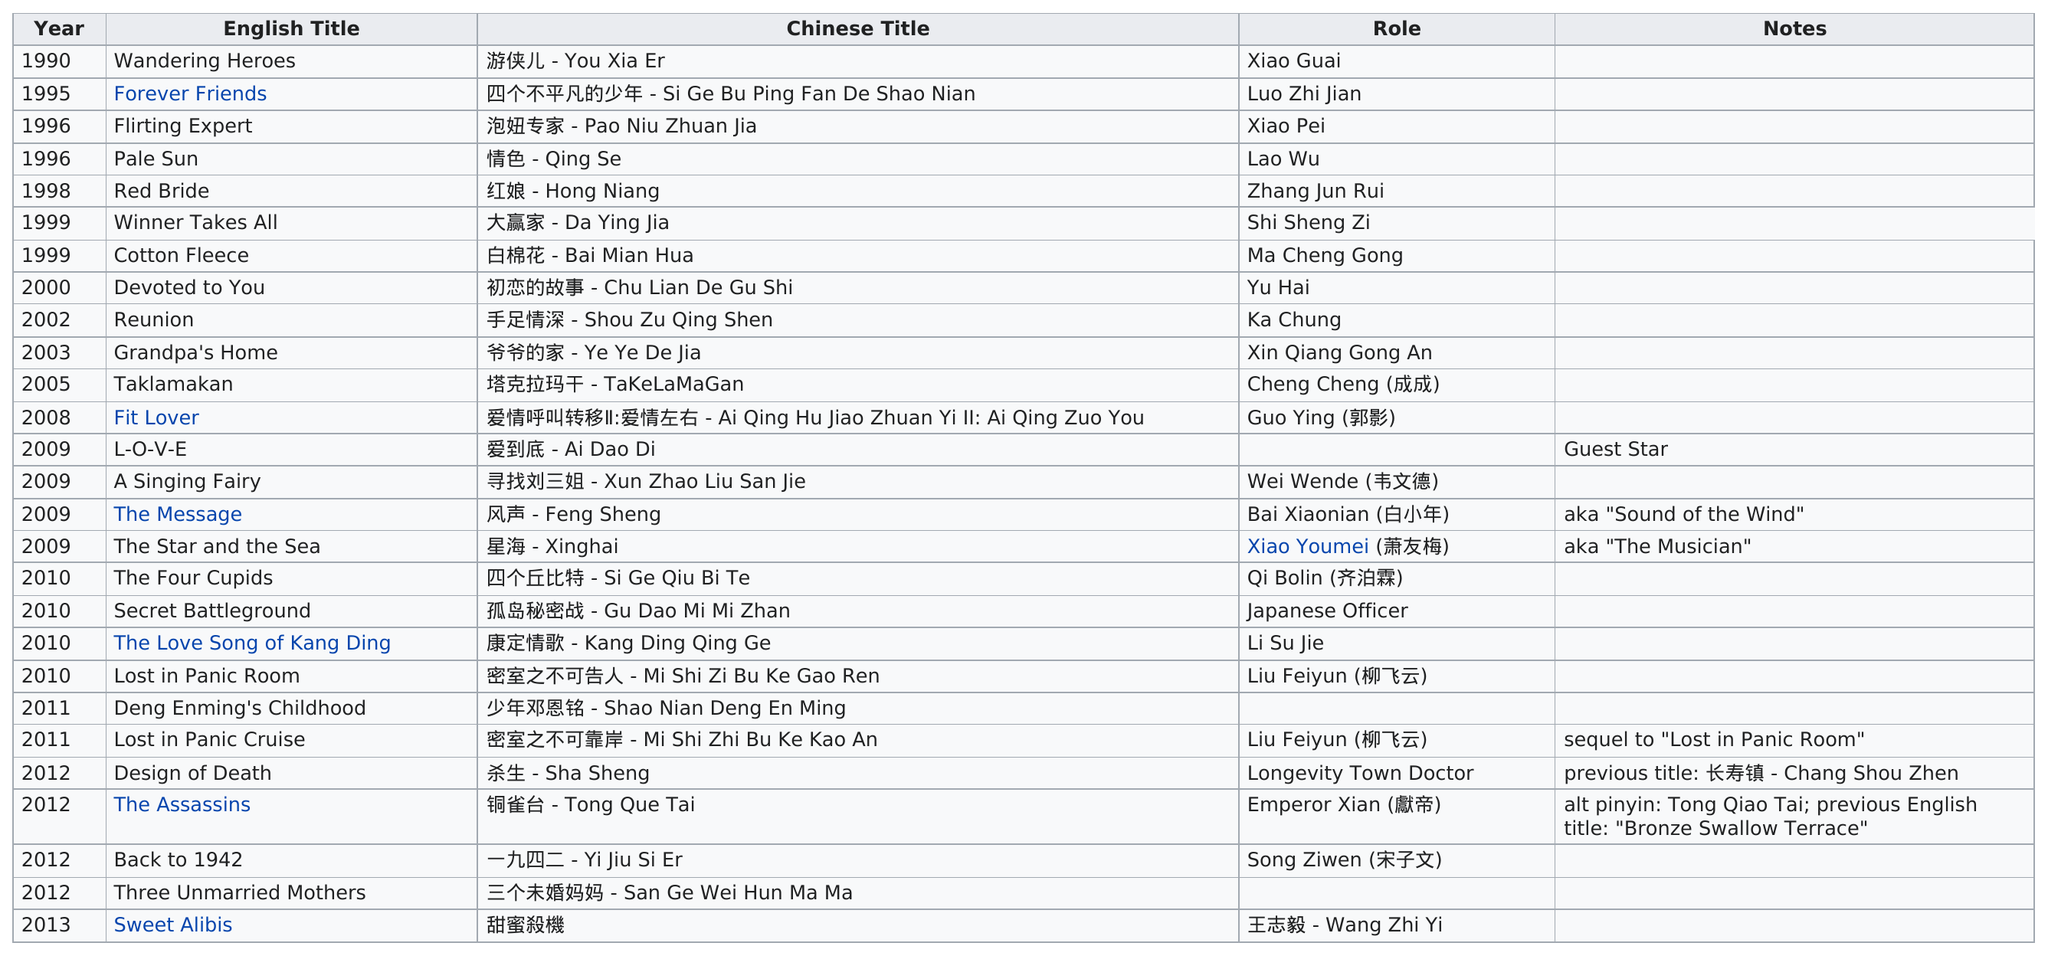Point out several critical features in this image. Has this actor been in more than 15 films or fewer than 15 films? In the period between 1990 and 2000, he made a total of 8 films. In 2011, Alec Su was featured in the least number of films after 2008. The previous title of the design of death was '长寿镇 - Chang Shou Zhen', a name that reflects the community's long-standing tradition of celebrating life and death in equal measure. The total number of English titles is 27. 